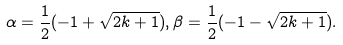<formula> <loc_0><loc_0><loc_500><loc_500>\alpha = \frac { 1 } { 2 } ( - 1 + \sqrt { 2 k + 1 } ) , \beta = \frac { 1 } { 2 } ( - 1 - \sqrt { 2 k + 1 } ) .</formula> 